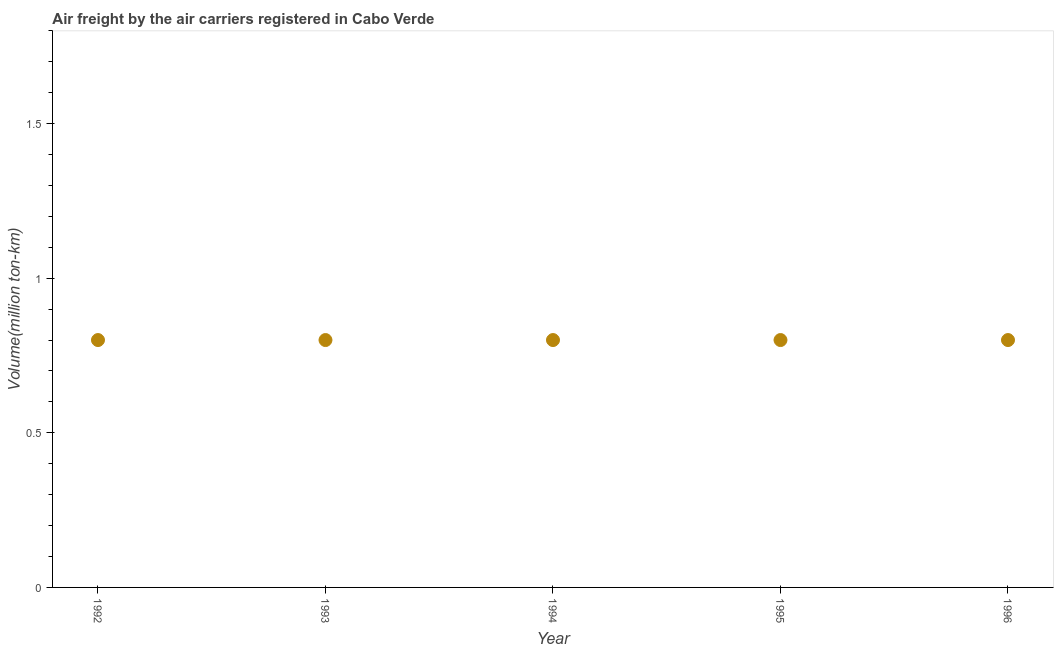What is the air freight in 1993?
Provide a short and direct response. 0.8. Across all years, what is the maximum air freight?
Make the answer very short. 0.8. Across all years, what is the minimum air freight?
Offer a very short reply. 0.8. In which year was the air freight maximum?
Provide a short and direct response. 1992. What is the sum of the air freight?
Offer a terse response. 4. What is the average air freight per year?
Offer a very short reply. 0.8. What is the median air freight?
Your answer should be very brief. 0.8. Do a majority of the years between 1996 and 1992 (inclusive) have air freight greater than 1.6 million ton-km?
Ensure brevity in your answer.  Yes. Is the air freight in 1992 less than that in 1995?
Your answer should be very brief. No. Is the sum of the air freight in 1992 and 1996 greater than the maximum air freight across all years?
Offer a very short reply. Yes. What is the difference between the highest and the lowest air freight?
Your answer should be very brief. 0. In how many years, is the air freight greater than the average air freight taken over all years?
Give a very brief answer. 0. How many dotlines are there?
Make the answer very short. 1. What is the difference between two consecutive major ticks on the Y-axis?
Provide a succinct answer. 0.5. Does the graph contain any zero values?
Your answer should be compact. No. Does the graph contain grids?
Offer a very short reply. No. What is the title of the graph?
Ensure brevity in your answer.  Air freight by the air carriers registered in Cabo Verde. What is the label or title of the X-axis?
Give a very brief answer. Year. What is the label or title of the Y-axis?
Provide a succinct answer. Volume(million ton-km). What is the Volume(million ton-km) in 1992?
Keep it short and to the point. 0.8. What is the Volume(million ton-km) in 1993?
Your answer should be very brief. 0.8. What is the Volume(million ton-km) in 1994?
Your answer should be very brief. 0.8. What is the Volume(million ton-km) in 1995?
Make the answer very short. 0.8. What is the Volume(million ton-km) in 1996?
Make the answer very short. 0.8. What is the difference between the Volume(million ton-km) in 1992 and 1993?
Keep it short and to the point. 0. What is the difference between the Volume(million ton-km) in 1993 and 1994?
Your response must be concise. 0. What is the difference between the Volume(million ton-km) in 1993 and 1996?
Provide a succinct answer. 0. What is the difference between the Volume(million ton-km) in 1994 and 1996?
Your answer should be very brief. 0. What is the difference between the Volume(million ton-km) in 1995 and 1996?
Your answer should be very brief. 0. What is the ratio of the Volume(million ton-km) in 1992 to that in 1993?
Keep it short and to the point. 1. What is the ratio of the Volume(million ton-km) in 1992 to that in 1996?
Provide a short and direct response. 1. What is the ratio of the Volume(million ton-km) in 1993 to that in 1994?
Provide a succinct answer. 1. What is the ratio of the Volume(million ton-km) in 1993 to that in 1995?
Keep it short and to the point. 1. What is the ratio of the Volume(million ton-km) in 1993 to that in 1996?
Your answer should be compact. 1. What is the ratio of the Volume(million ton-km) in 1994 to that in 1996?
Your answer should be compact. 1. What is the ratio of the Volume(million ton-km) in 1995 to that in 1996?
Make the answer very short. 1. 